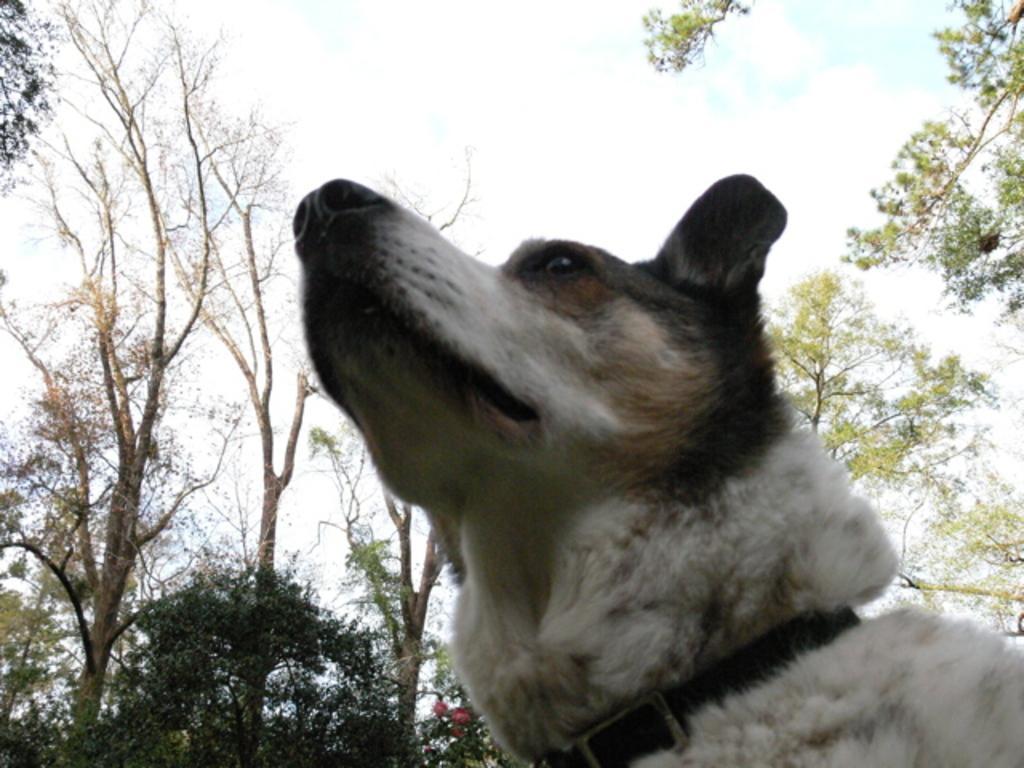In one or two sentences, can you explain what this image depicts? In this image we can see a dog, plants, trees and sky with clouds. 